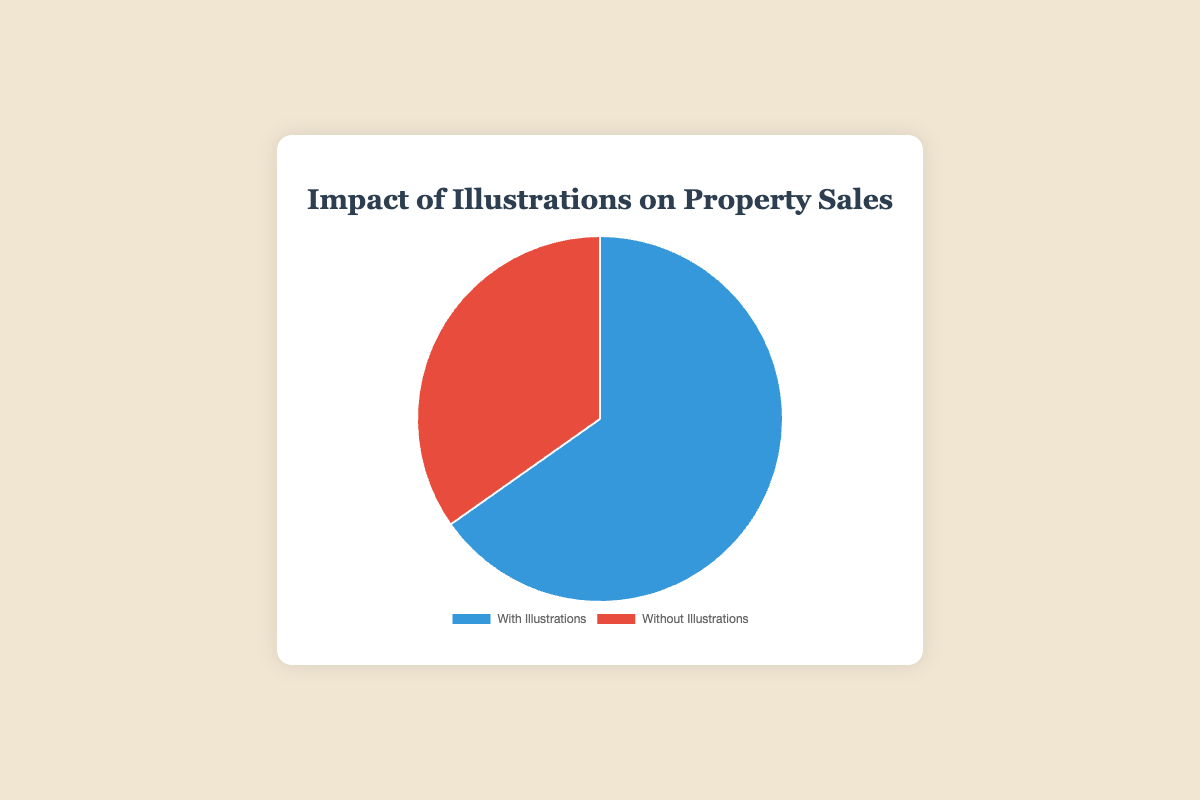Which category of properties sold more? The figure shows two categories. By comparing the sizes of the sections, we see that "Properties Sold with Illustrations" has a larger size.
Answer: Properties Sold with Illustrations How many more properties were sold with illustrations compared to without illustrations? To find the difference, subtract the count of properties sold without illustrations (80) from the count of properties sold with illustrations (150). 150 - 80 = 70
Answer: 70 What is the total number of properties sold in the campaign? To find the total, add the count of properties sold with illustrations (150) to the count of properties sold without illustrations (80). 150 + 80 = 230
Answer: 230 What percentage of the total properties sold had illustrations? To find the percentage, divide the count of properties sold with illustrations (150) by the total properties sold (230) and multiply by 100. \( \frac{150}{230} \times 100 = 65.2\% \)
Answer: 65.2% Which section of the pie chart is colored blue? The pie chart uses blue for "Properties Sold with Illustrations."
Answer: Properties Sold with Illustrations What is the ratio of properties sold with illustrations to properties sold without illustrations? To find the ratio, divide the count of properties sold with illustrations (150) by the count of properties sold without illustrations (80). \( \frac{150}{80} = 1.875 \)
Answer: 1.875 Is there a significant difference in the number of properties sold between the two categories? Yes, there is a significant difference as "Properties Sold with Illustrations" (150) is almost double that of "Properties Sold without Illustrations" (80).
Answer: Yes How many properties sold without illustrations as a percentage of the total? To find the percentage, divide the count of properties sold without illustrations (80) by the total properties sold (230) and multiply by 100. \( \frac{80}{230} \times 100 = 34.8\% \)
Answer: 34.8% If an additional 20 properties were sold without illustrations, would this change the majority? Adding 20 more properties to the "without illustrations" category makes it 100. The new total would be 250. Properties with illustrations would still be a majority as 150 > 100.
Answer: No What fraction of properties sold had illustrations? To find the fraction, divide the count of properties sold with illustrations (150) by the total properties sold (230). \( \frac{150}{230} = \frac{15}{23} \)
Answer: 15/23 